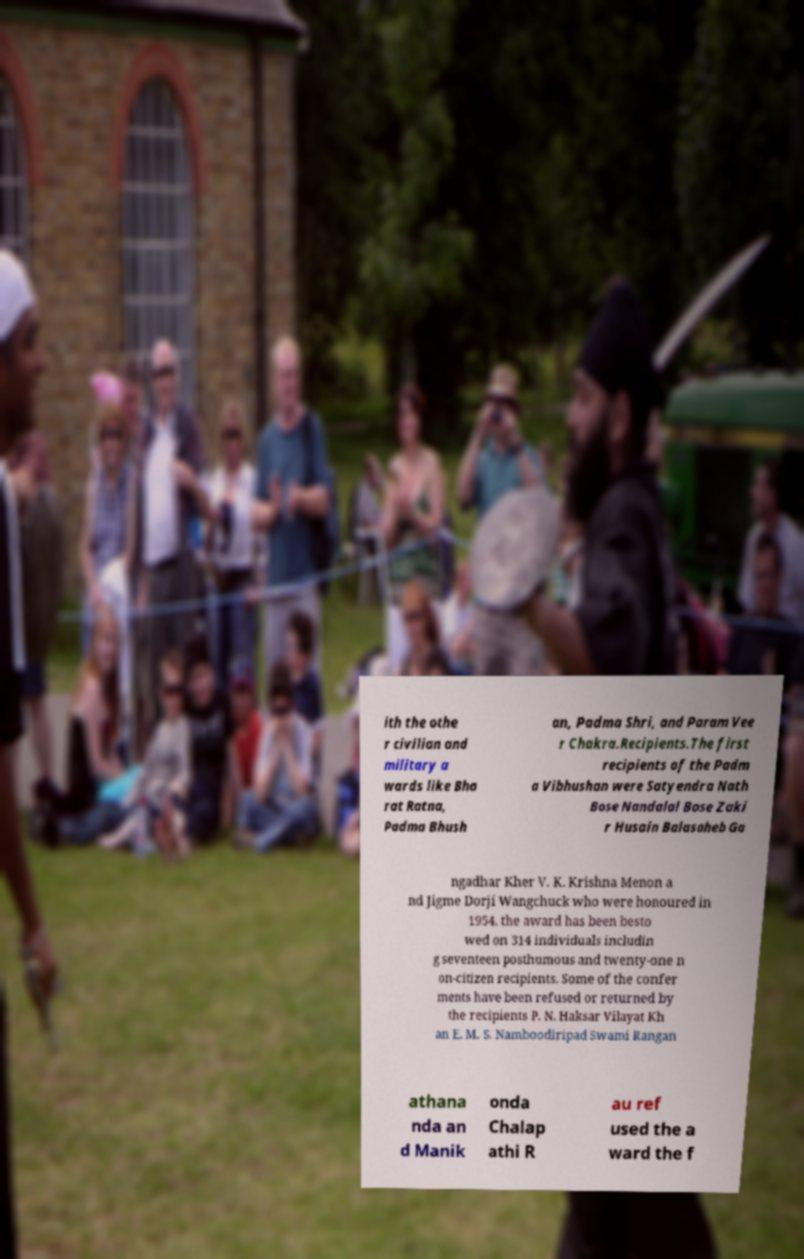Could you assist in decoding the text presented in this image and type it out clearly? ith the othe r civilian and military a wards like Bha rat Ratna, Padma Bhush an, Padma Shri, and Param Vee r Chakra.Recipients.The first recipients of the Padm a Vibhushan were Satyendra Nath Bose Nandalal Bose Zaki r Husain Balasaheb Ga ngadhar Kher V. K. Krishna Menon a nd Jigme Dorji Wangchuck who were honoured in 1954. the award has been besto wed on 314 individuals includin g seventeen posthumous and twenty-one n on-citizen recipients. Some of the confer ments have been refused or returned by the recipients P. N. Haksar Vilayat Kh an E. M. S. Namboodiripad Swami Rangan athana nda an d Manik onda Chalap athi R au ref used the a ward the f 